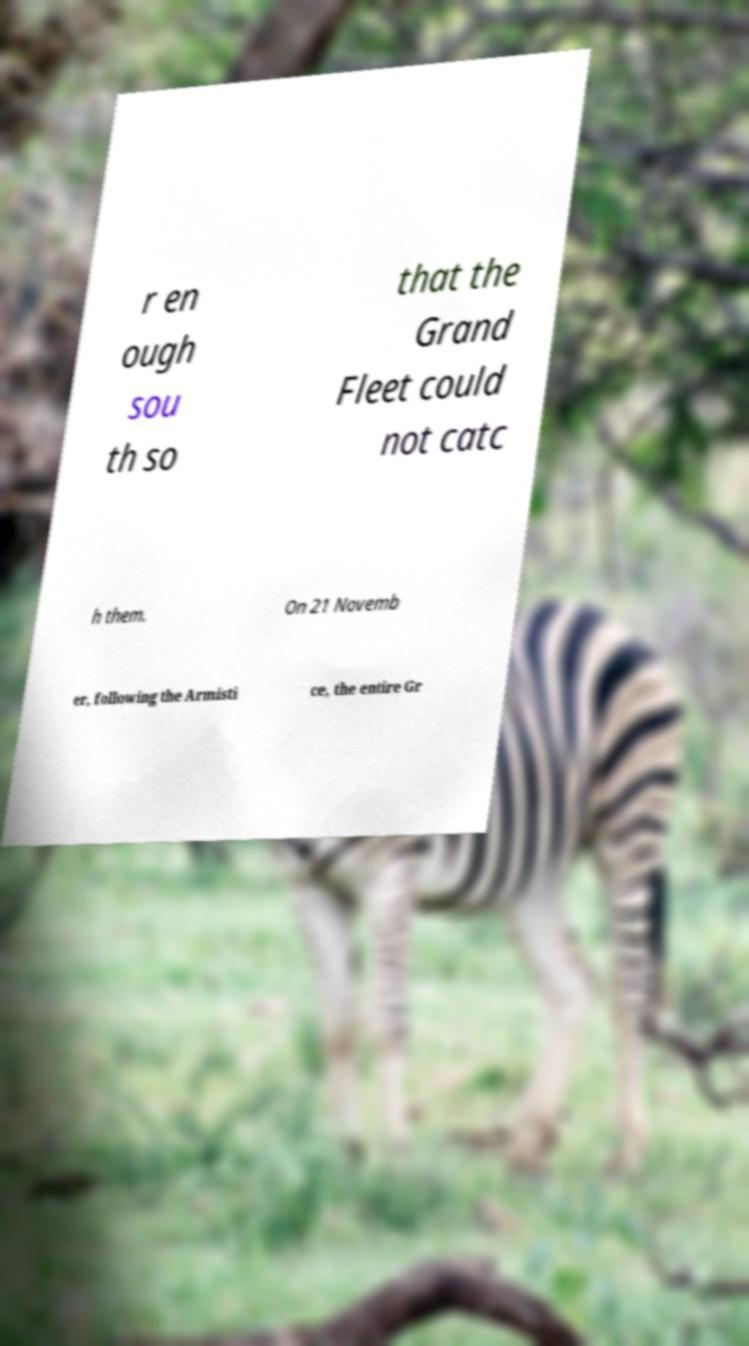There's text embedded in this image that I need extracted. Can you transcribe it verbatim? r en ough sou th so that the Grand Fleet could not catc h them. On 21 Novemb er, following the Armisti ce, the entire Gr 